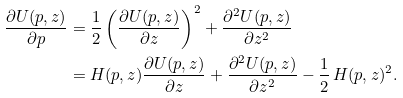Convert formula to latex. <formula><loc_0><loc_0><loc_500><loc_500>\frac { \partial U ( p , z ) } { \partial p } & = \frac { 1 } { 2 } \left ( \frac { \partial U ( p , z ) } { \partial z } \right ) ^ { 2 } + \frac { \partial ^ { 2 } U ( p , z ) } { \partial z ^ { 2 } } \\ & = H ( p , z ) \frac { \partial U ( p , z ) } { \partial z } + \frac { \partial ^ { 2 } U ( p , z ) } { \partial z ^ { 2 } } - \frac { 1 } { 2 } \, H ( p , z ) ^ { 2 } .</formula> 